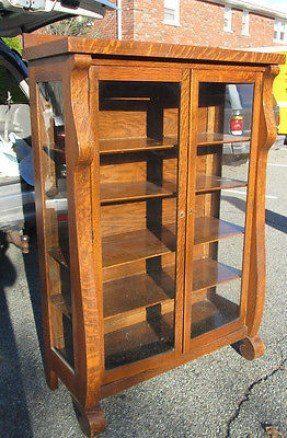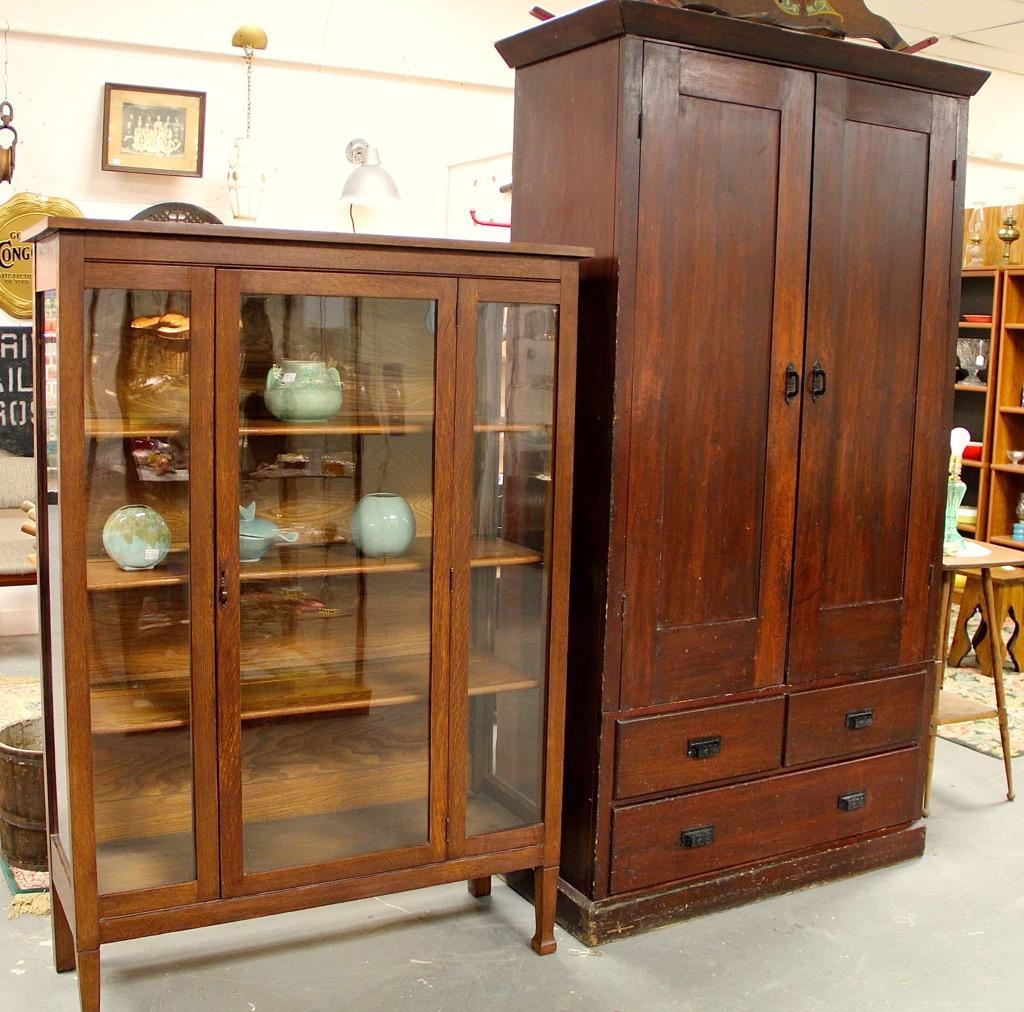The first image is the image on the left, the second image is the image on the right. Given the left and right images, does the statement "All images show a piece of furniture with drawers" hold true? Answer yes or no. No. 